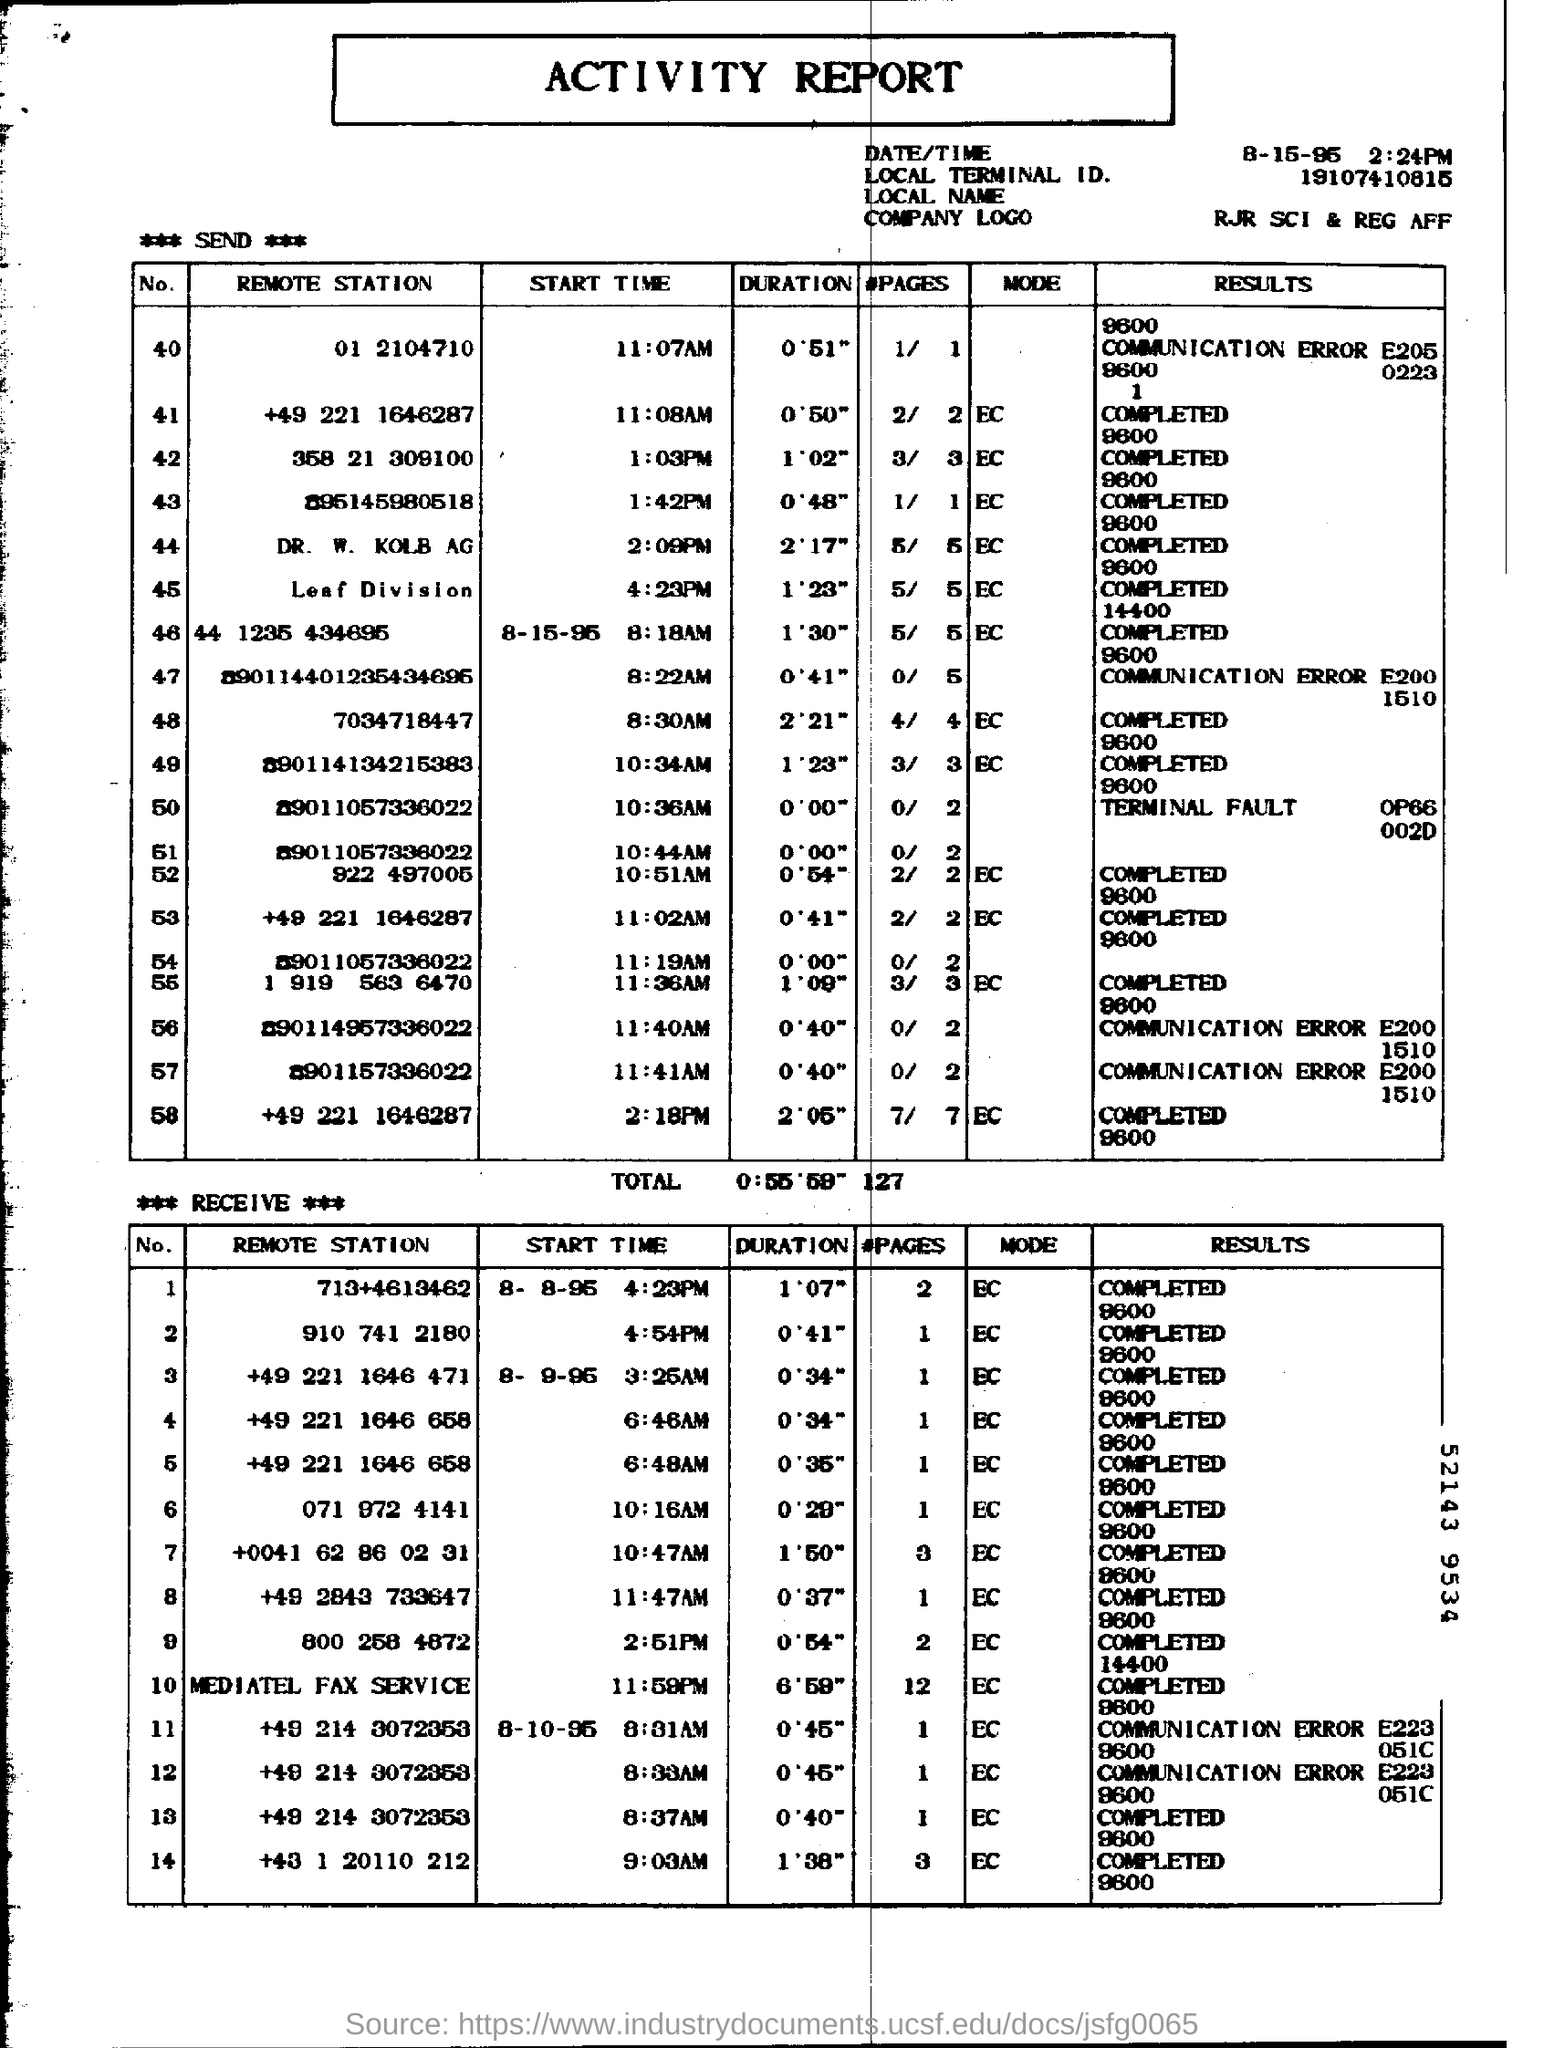Mention a couple of crucial points in this snapshot. What is the remote station number 40? It is 01 and its identification code is 2104710. The document title is an Activity Report. 